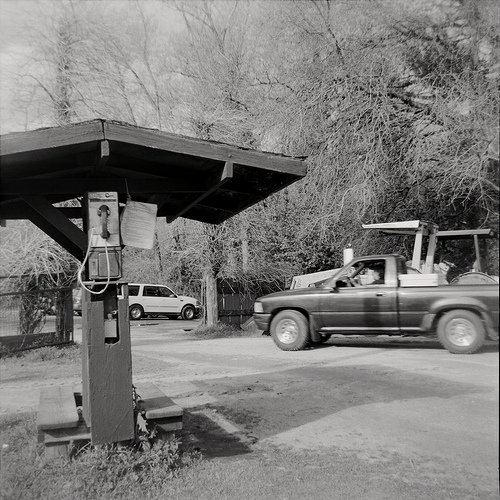Describe the overall scene depicted in the image. The image shows a rural or suburban setting with a wooden awning structure under which there is a pay phone attached to a wooden pole. There are benches under the awning. In the background, there is an open space with trees and two vehicles: a truck with a man inside and another car parked further back. The scene appears quite calm and typical of a small neighborhood or rural area. What details in the image tell you about the possible era this photo might have been taken? The presence of a pay phone suggests this photo could be from a time when mobile phones were not as prevalent, possibly the 1980s or 1990s. Additionally, the style of the vehicles and the overall look and feel of the wooden structure contribute to the impression that this image was taken several decades ago. What does the man in the truck seem to be doing? The man in the truck appears to be driving, as he is seated behind the wheel with his arm resting on the door. He might be passing by the area where the pay phone and wooden structure are located. Imagine this image is part of a larger story. What might be happening next? In the larger story, the man in the truck might be stopping to use the pay phone to make an important call. Perhaps he needs to contact someone urgently or get directions. Meanwhile, another individual might arrive, perhaps on foot, to also use the phone or seek shelter under the awning. The scene might further develop with a conversation between the two, exchanging news or information relevant to their small community. 